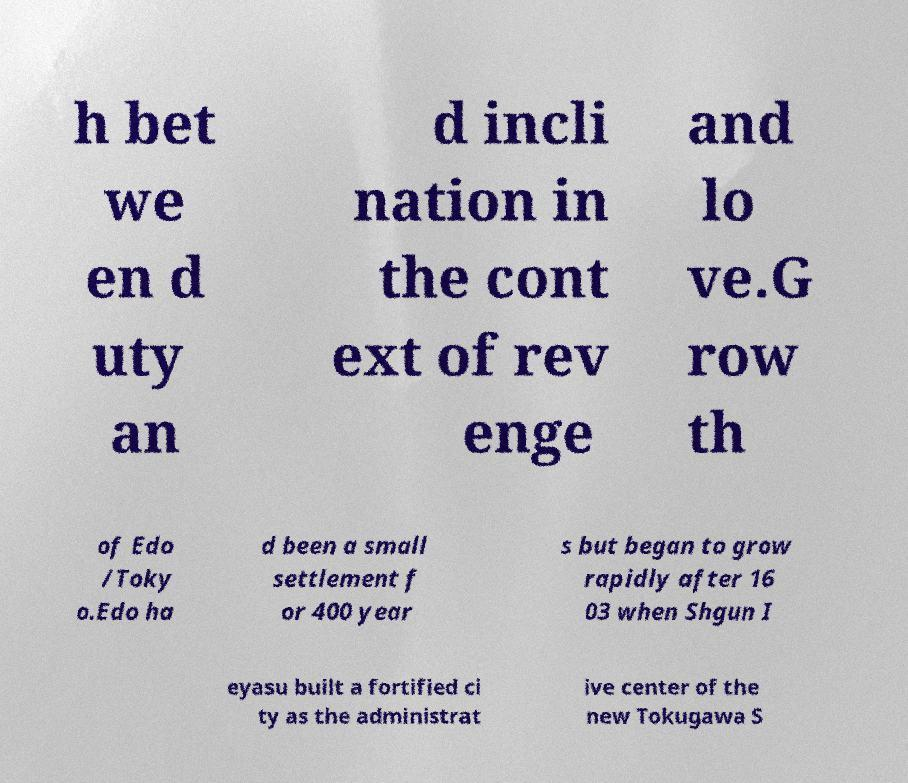Can you accurately transcribe the text from the provided image for me? h bet we en d uty an d incli nation in the cont ext of rev enge and lo ve.G row th of Edo /Toky o.Edo ha d been a small settlement f or 400 year s but began to grow rapidly after 16 03 when Shgun I eyasu built a fortified ci ty as the administrat ive center of the new Tokugawa S 